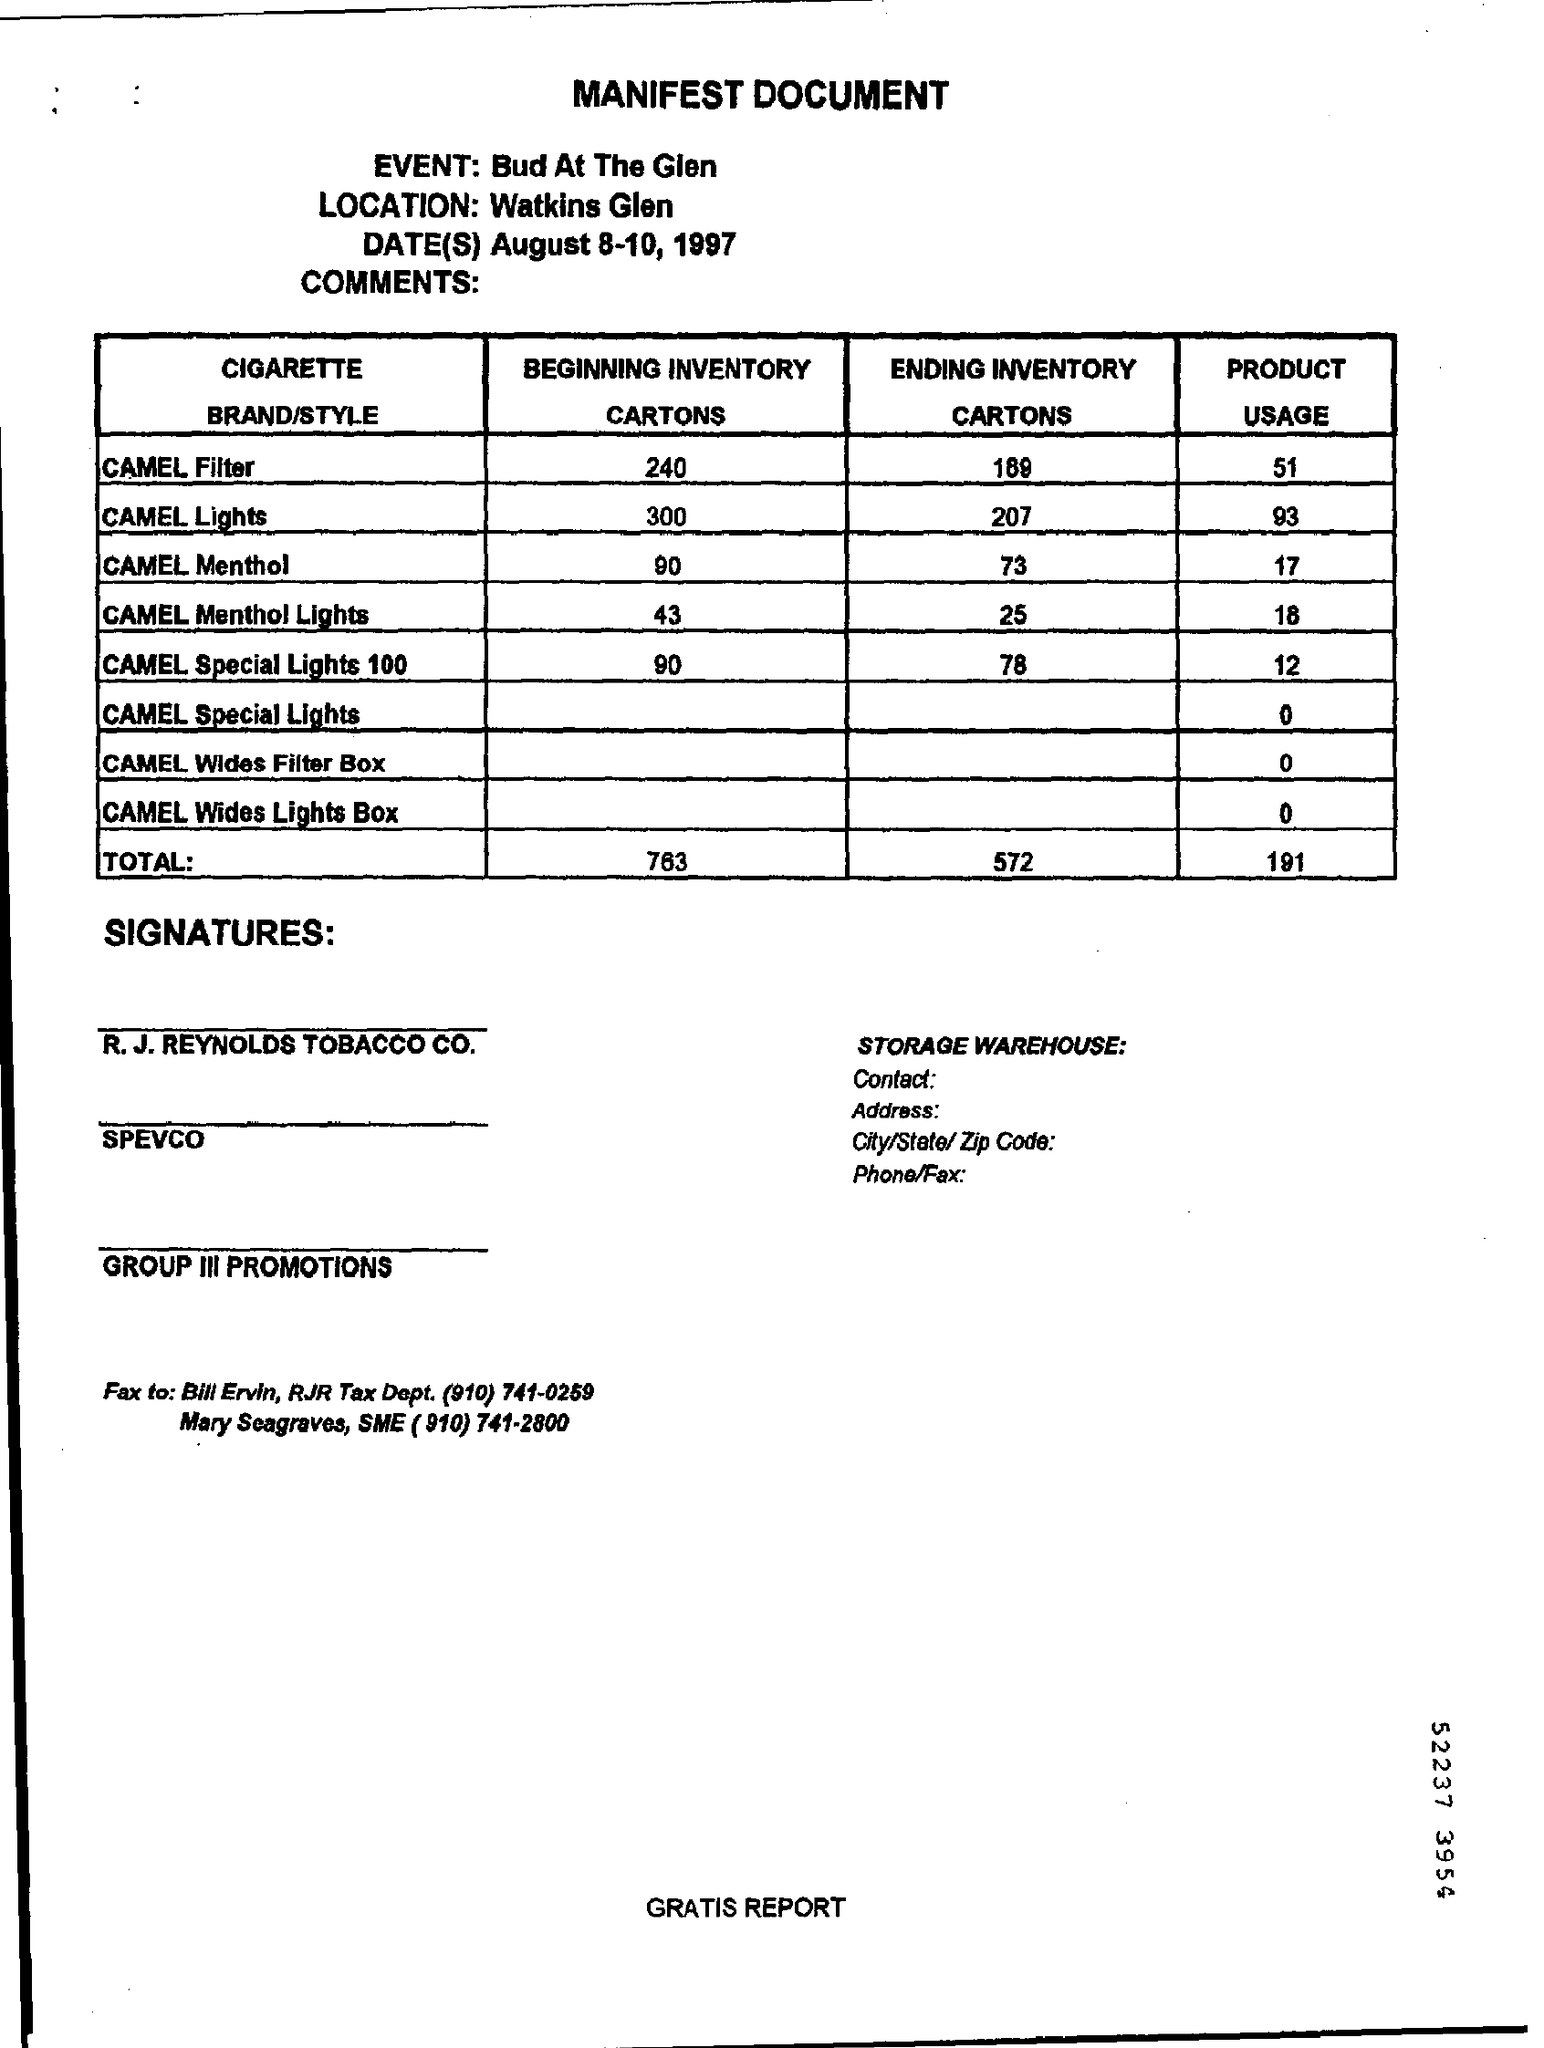Title of the document?
Provide a succinct answer. MANIFEST DOCUMENT. Which location is mentioned in heading?
Keep it short and to the point. Watkins Glen. What is the beginning inventory of camel menthol?
Make the answer very short. 90. 